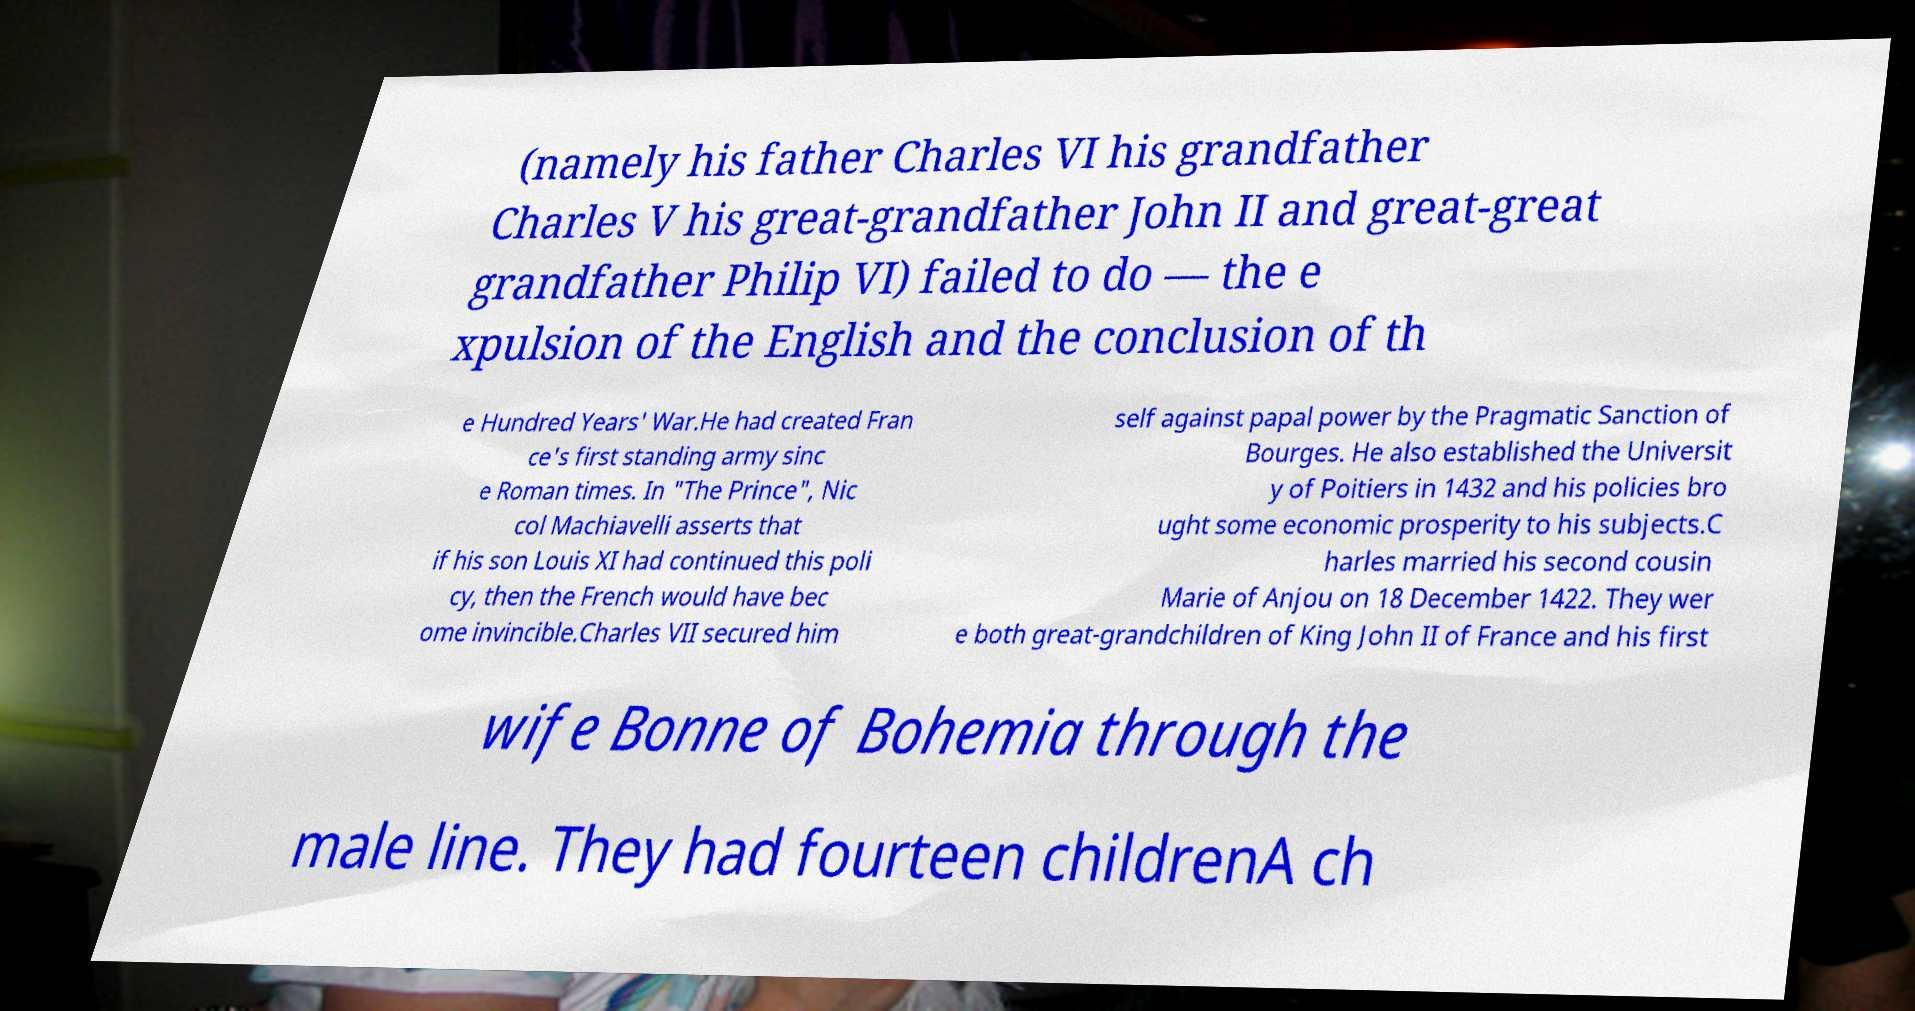For documentation purposes, I need the text within this image transcribed. Could you provide that? (namely his father Charles VI his grandfather Charles V his great-grandfather John II and great-great grandfather Philip VI) failed to do — the e xpulsion of the English and the conclusion of th e Hundred Years' War.He had created Fran ce's first standing army sinc e Roman times. In "The Prince", Nic col Machiavelli asserts that if his son Louis XI had continued this poli cy, then the French would have bec ome invincible.Charles VII secured him self against papal power by the Pragmatic Sanction of Bourges. He also established the Universit y of Poitiers in 1432 and his policies bro ught some economic prosperity to his subjects.C harles married his second cousin Marie of Anjou on 18 December 1422. They wer e both great-grandchildren of King John II of France and his first wife Bonne of Bohemia through the male line. They had fourteen childrenA ch 